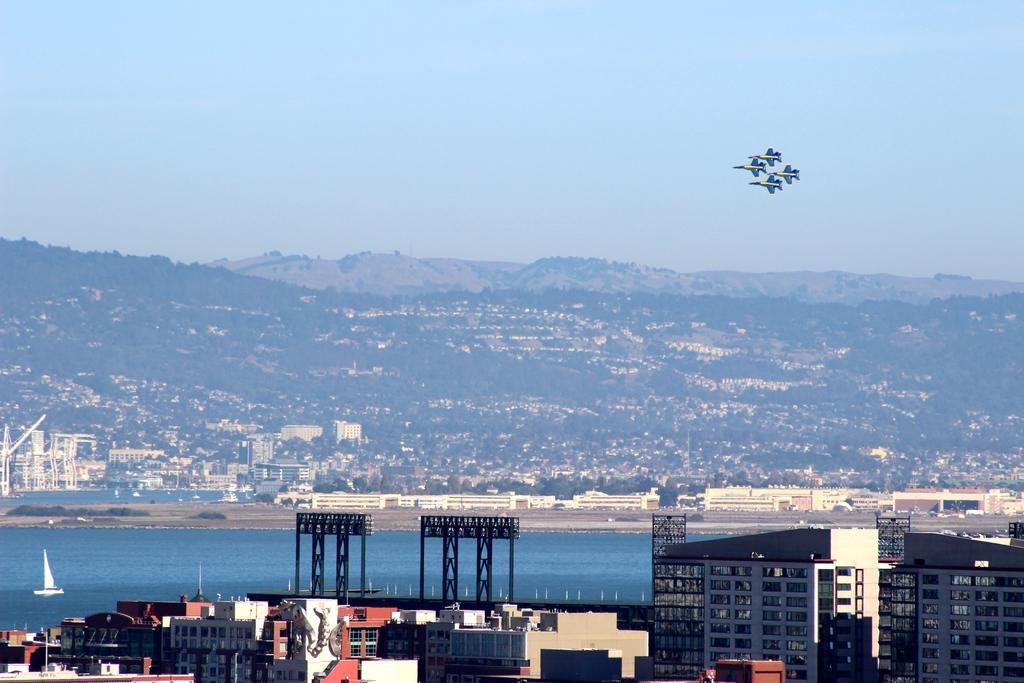Can you describe this image briefly? In the image in the foreground there are building. In the middle there is water body. In the background there are hills, buildings, trees. In the sky for airplanes are flying. The sky is clear. 